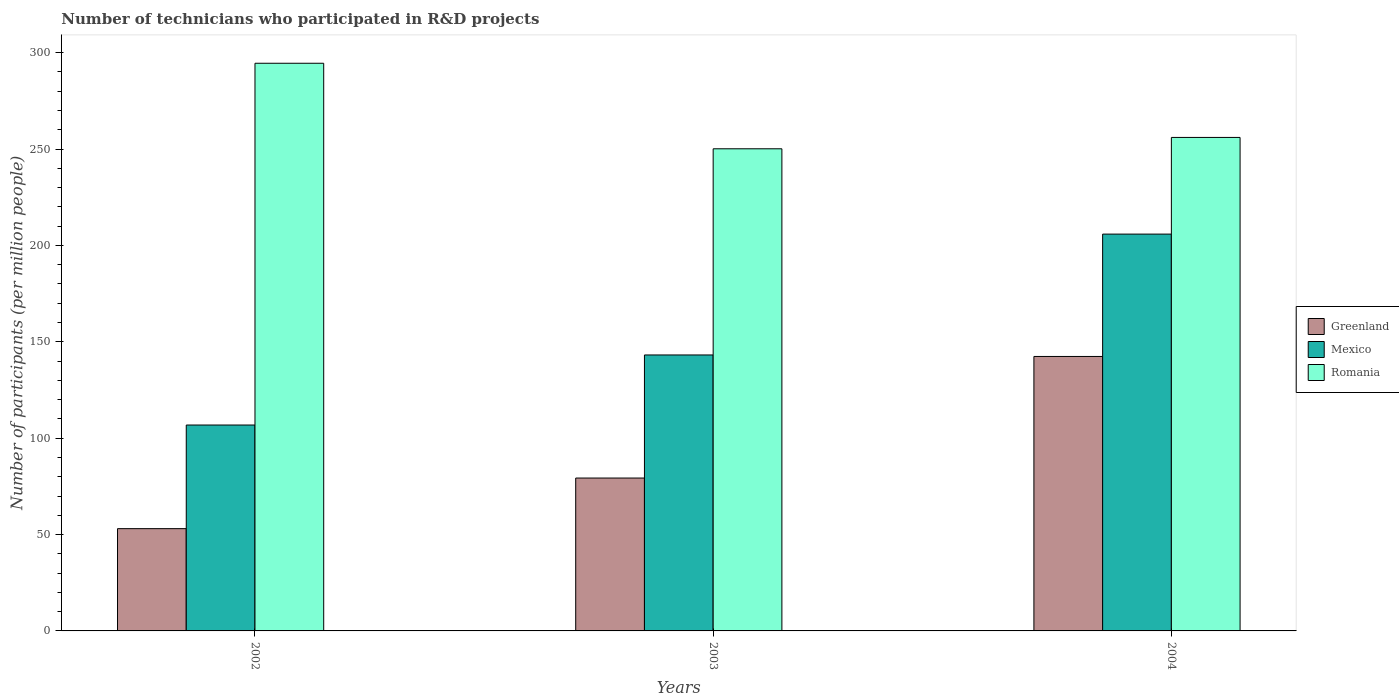How many different coloured bars are there?
Ensure brevity in your answer.  3. Are the number of bars per tick equal to the number of legend labels?
Keep it short and to the point. Yes. How many bars are there on the 1st tick from the left?
Your response must be concise. 3. What is the label of the 2nd group of bars from the left?
Make the answer very short. 2003. What is the number of technicians who participated in R&D projects in Greenland in 2004?
Your answer should be compact. 142.4. Across all years, what is the maximum number of technicians who participated in R&D projects in Mexico?
Keep it short and to the point. 205.89. Across all years, what is the minimum number of technicians who participated in R&D projects in Greenland?
Your answer should be very brief. 53.07. In which year was the number of technicians who participated in R&D projects in Romania maximum?
Give a very brief answer. 2002. In which year was the number of technicians who participated in R&D projects in Romania minimum?
Offer a very short reply. 2003. What is the total number of technicians who participated in R&D projects in Romania in the graph?
Ensure brevity in your answer.  800.72. What is the difference between the number of technicians who participated in R&D projects in Greenland in 2002 and that in 2004?
Keep it short and to the point. -89.34. What is the difference between the number of technicians who participated in R&D projects in Romania in 2002 and the number of technicians who participated in R&D projects in Greenland in 2004?
Keep it short and to the point. 152.12. What is the average number of technicians who participated in R&D projects in Mexico per year?
Give a very brief answer. 151.97. In the year 2002, what is the difference between the number of technicians who participated in R&D projects in Greenland and number of technicians who participated in R&D projects in Mexico?
Provide a succinct answer. -53.77. What is the ratio of the number of technicians who participated in R&D projects in Romania in 2003 to that in 2004?
Offer a terse response. 0.98. Is the difference between the number of technicians who participated in R&D projects in Greenland in 2002 and 2004 greater than the difference between the number of technicians who participated in R&D projects in Mexico in 2002 and 2004?
Provide a short and direct response. Yes. What is the difference between the highest and the second highest number of technicians who participated in R&D projects in Romania?
Provide a short and direct response. 38.48. What is the difference between the highest and the lowest number of technicians who participated in R&D projects in Greenland?
Offer a terse response. 89.34. What does the 3rd bar from the left in 2002 represents?
Offer a terse response. Romania. What does the 1st bar from the right in 2003 represents?
Provide a succinct answer. Romania. How many bars are there?
Your response must be concise. 9. How many years are there in the graph?
Your answer should be compact. 3. Does the graph contain any zero values?
Offer a terse response. No. How are the legend labels stacked?
Your answer should be very brief. Vertical. What is the title of the graph?
Offer a very short reply. Number of technicians who participated in R&D projects. What is the label or title of the X-axis?
Keep it short and to the point. Years. What is the label or title of the Y-axis?
Give a very brief answer. Number of participants (per million people). What is the Number of participants (per million people) in Greenland in 2002?
Offer a terse response. 53.07. What is the Number of participants (per million people) in Mexico in 2002?
Provide a succinct answer. 106.83. What is the Number of participants (per million people) of Romania in 2002?
Your answer should be compact. 294.53. What is the Number of participants (per million people) in Greenland in 2003?
Give a very brief answer. 79.32. What is the Number of participants (per million people) of Mexico in 2003?
Provide a succinct answer. 143.18. What is the Number of participants (per million people) in Romania in 2003?
Ensure brevity in your answer.  250.15. What is the Number of participants (per million people) of Greenland in 2004?
Your response must be concise. 142.4. What is the Number of participants (per million people) of Mexico in 2004?
Ensure brevity in your answer.  205.89. What is the Number of participants (per million people) of Romania in 2004?
Offer a very short reply. 256.04. Across all years, what is the maximum Number of participants (per million people) in Greenland?
Provide a succinct answer. 142.4. Across all years, what is the maximum Number of participants (per million people) in Mexico?
Provide a short and direct response. 205.89. Across all years, what is the maximum Number of participants (per million people) of Romania?
Keep it short and to the point. 294.53. Across all years, what is the minimum Number of participants (per million people) in Greenland?
Make the answer very short. 53.07. Across all years, what is the minimum Number of participants (per million people) of Mexico?
Your response must be concise. 106.83. Across all years, what is the minimum Number of participants (per million people) of Romania?
Your response must be concise. 250.15. What is the total Number of participants (per million people) of Greenland in the graph?
Your response must be concise. 274.79. What is the total Number of participants (per million people) of Mexico in the graph?
Provide a short and direct response. 455.9. What is the total Number of participants (per million people) in Romania in the graph?
Keep it short and to the point. 800.72. What is the difference between the Number of participants (per million people) in Greenland in 2002 and that in 2003?
Offer a terse response. -26.25. What is the difference between the Number of participants (per million people) in Mexico in 2002 and that in 2003?
Give a very brief answer. -36.35. What is the difference between the Number of participants (per million people) of Romania in 2002 and that in 2003?
Offer a very short reply. 44.37. What is the difference between the Number of participants (per million people) in Greenland in 2002 and that in 2004?
Make the answer very short. -89.34. What is the difference between the Number of participants (per million people) in Mexico in 2002 and that in 2004?
Offer a terse response. -99.06. What is the difference between the Number of participants (per million people) of Romania in 2002 and that in 2004?
Your answer should be very brief. 38.48. What is the difference between the Number of participants (per million people) of Greenland in 2003 and that in 2004?
Ensure brevity in your answer.  -63.08. What is the difference between the Number of participants (per million people) of Mexico in 2003 and that in 2004?
Make the answer very short. -62.71. What is the difference between the Number of participants (per million people) in Romania in 2003 and that in 2004?
Your answer should be very brief. -5.89. What is the difference between the Number of participants (per million people) of Greenland in 2002 and the Number of participants (per million people) of Mexico in 2003?
Offer a very short reply. -90.11. What is the difference between the Number of participants (per million people) in Greenland in 2002 and the Number of participants (per million people) in Romania in 2003?
Offer a very short reply. -197.09. What is the difference between the Number of participants (per million people) of Mexico in 2002 and the Number of participants (per million people) of Romania in 2003?
Give a very brief answer. -143.32. What is the difference between the Number of participants (per million people) in Greenland in 2002 and the Number of participants (per million people) in Mexico in 2004?
Give a very brief answer. -152.82. What is the difference between the Number of participants (per million people) of Greenland in 2002 and the Number of participants (per million people) of Romania in 2004?
Your answer should be compact. -202.98. What is the difference between the Number of participants (per million people) in Mexico in 2002 and the Number of participants (per million people) in Romania in 2004?
Make the answer very short. -149.21. What is the difference between the Number of participants (per million people) of Greenland in 2003 and the Number of participants (per million people) of Mexico in 2004?
Ensure brevity in your answer.  -126.57. What is the difference between the Number of participants (per million people) of Greenland in 2003 and the Number of participants (per million people) of Romania in 2004?
Your answer should be very brief. -176.72. What is the difference between the Number of participants (per million people) in Mexico in 2003 and the Number of participants (per million people) in Romania in 2004?
Ensure brevity in your answer.  -112.87. What is the average Number of participants (per million people) of Greenland per year?
Provide a short and direct response. 91.6. What is the average Number of participants (per million people) of Mexico per year?
Your answer should be compact. 151.97. What is the average Number of participants (per million people) of Romania per year?
Keep it short and to the point. 266.91. In the year 2002, what is the difference between the Number of participants (per million people) of Greenland and Number of participants (per million people) of Mexico?
Make the answer very short. -53.77. In the year 2002, what is the difference between the Number of participants (per million people) in Greenland and Number of participants (per million people) in Romania?
Provide a succinct answer. -241.46. In the year 2002, what is the difference between the Number of participants (per million people) in Mexico and Number of participants (per million people) in Romania?
Your answer should be compact. -187.7. In the year 2003, what is the difference between the Number of participants (per million people) in Greenland and Number of participants (per million people) in Mexico?
Provide a short and direct response. -63.86. In the year 2003, what is the difference between the Number of participants (per million people) of Greenland and Number of participants (per million people) of Romania?
Your answer should be compact. -170.83. In the year 2003, what is the difference between the Number of participants (per million people) in Mexico and Number of participants (per million people) in Romania?
Give a very brief answer. -106.98. In the year 2004, what is the difference between the Number of participants (per million people) of Greenland and Number of participants (per million people) of Mexico?
Offer a very short reply. -63.49. In the year 2004, what is the difference between the Number of participants (per million people) of Greenland and Number of participants (per million people) of Romania?
Your answer should be very brief. -113.64. In the year 2004, what is the difference between the Number of participants (per million people) in Mexico and Number of participants (per million people) in Romania?
Give a very brief answer. -50.16. What is the ratio of the Number of participants (per million people) of Greenland in 2002 to that in 2003?
Keep it short and to the point. 0.67. What is the ratio of the Number of participants (per million people) of Mexico in 2002 to that in 2003?
Your answer should be compact. 0.75. What is the ratio of the Number of participants (per million people) of Romania in 2002 to that in 2003?
Ensure brevity in your answer.  1.18. What is the ratio of the Number of participants (per million people) of Greenland in 2002 to that in 2004?
Your answer should be very brief. 0.37. What is the ratio of the Number of participants (per million people) in Mexico in 2002 to that in 2004?
Provide a short and direct response. 0.52. What is the ratio of the Number of participants (per million people) of Romania in 2002 to that in 2004?
Your answer should be compact. 1.15. What is the ratio of the Number of participants (per million people) of Greenland in 2003 to that in 2004?
Keep it short and to the point. 0.56. What is the ratio of the Number of participants (per million people) of Mexico in 2003 to that in 2004?
Give a very brief answer. 0.7. What is the ratio of the Number of participants (per million people) of Romania in 2003 to that in 2004?
Keep it short and to the point. 0.98. What is the difference between the highest and the second highest Number of participants (per million people) in Greenland?
Give a very brief answer. 63.08. What is the difference between the highest and the second highest Number of participants (per million people) in Mexico?
Your answer should be compact. 62.71. What is the difference between the highest and the second highest Number of participants (per million people) of Romania?
Give a very brief answer. 38.48. What is the difference between the highest and the lowest Number of participants (per million people) of Greenland?
Provide a succinct answer. 89.34. What is the difference between the highest and the lowest Number of participants (per million people) in Mexico?
Ensure brevity in your answer.  99.06. What is the difference between the highest and the lowest Number of participants (per million people) in Romania?
Give a very brief answer. 44.37. 